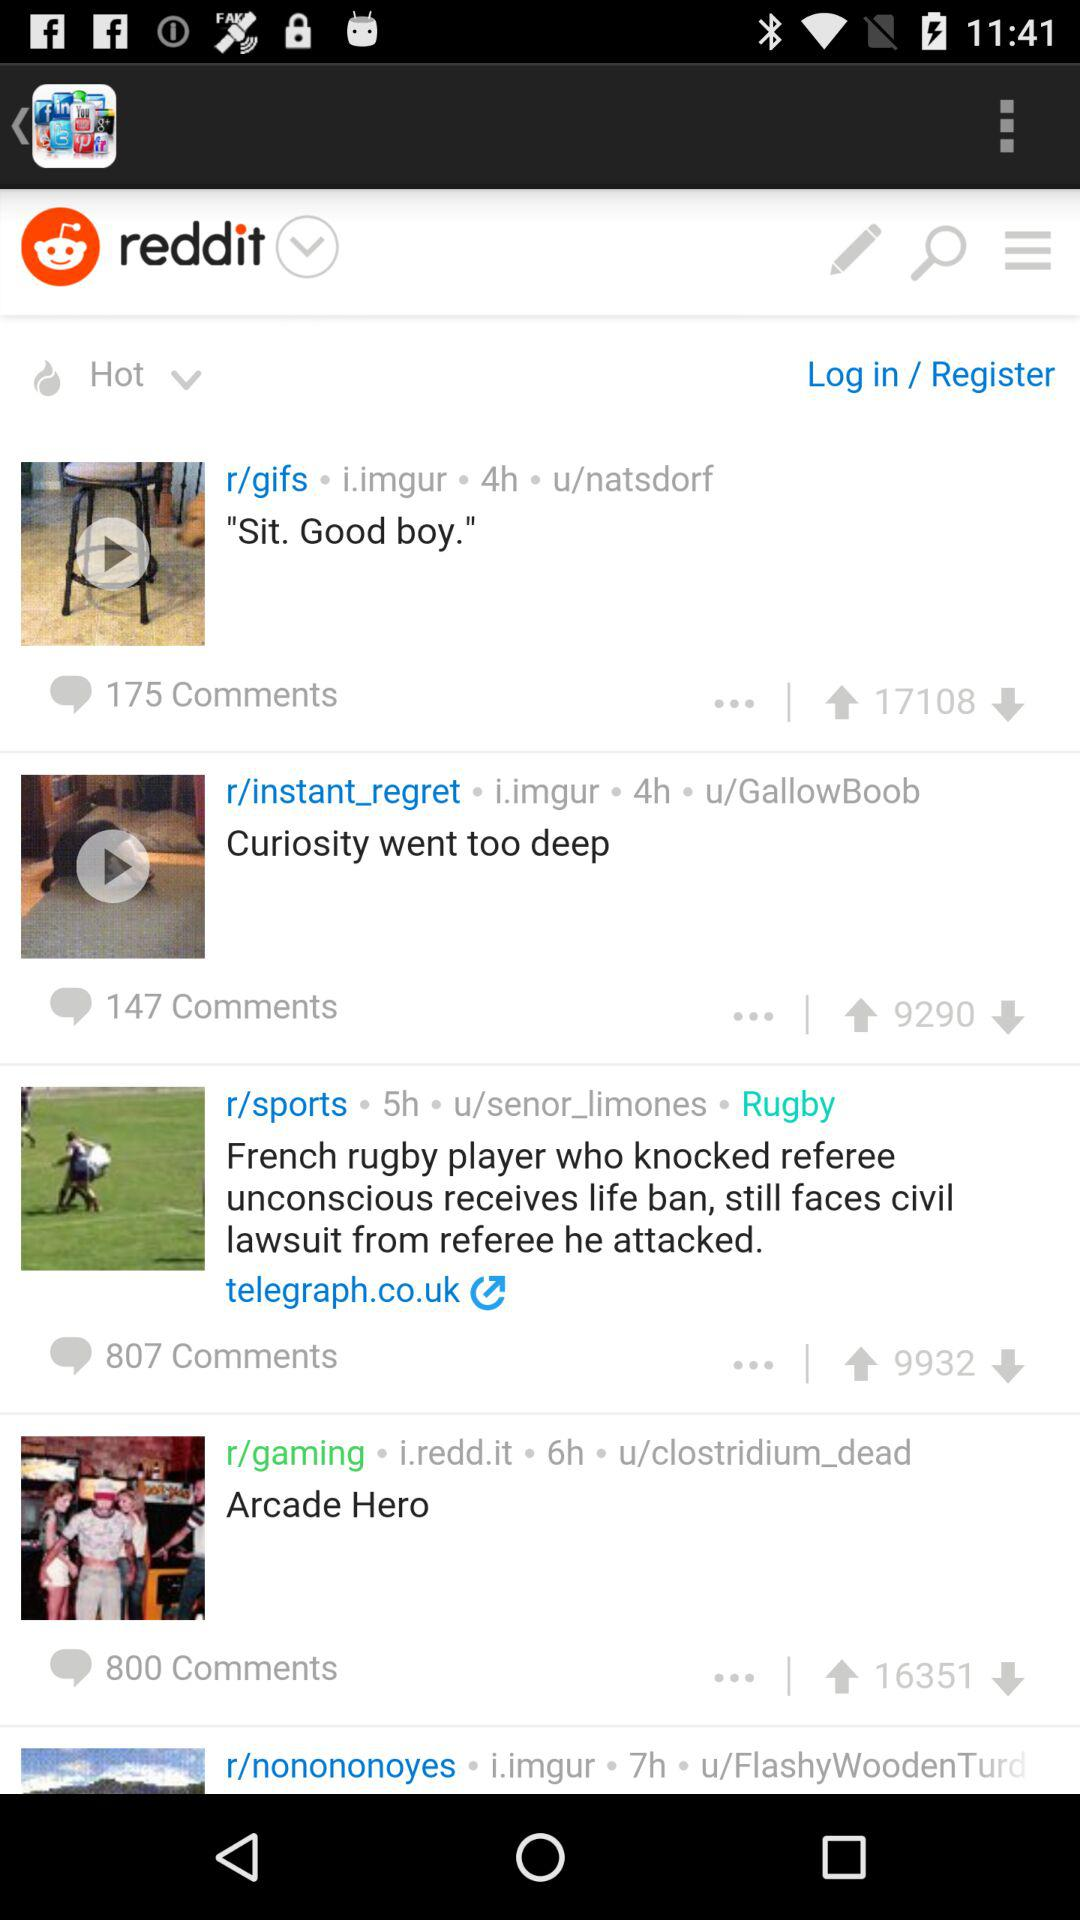How many comments are there on the post with the fewest comments?
Answer the question using a single word or phrase. 147 